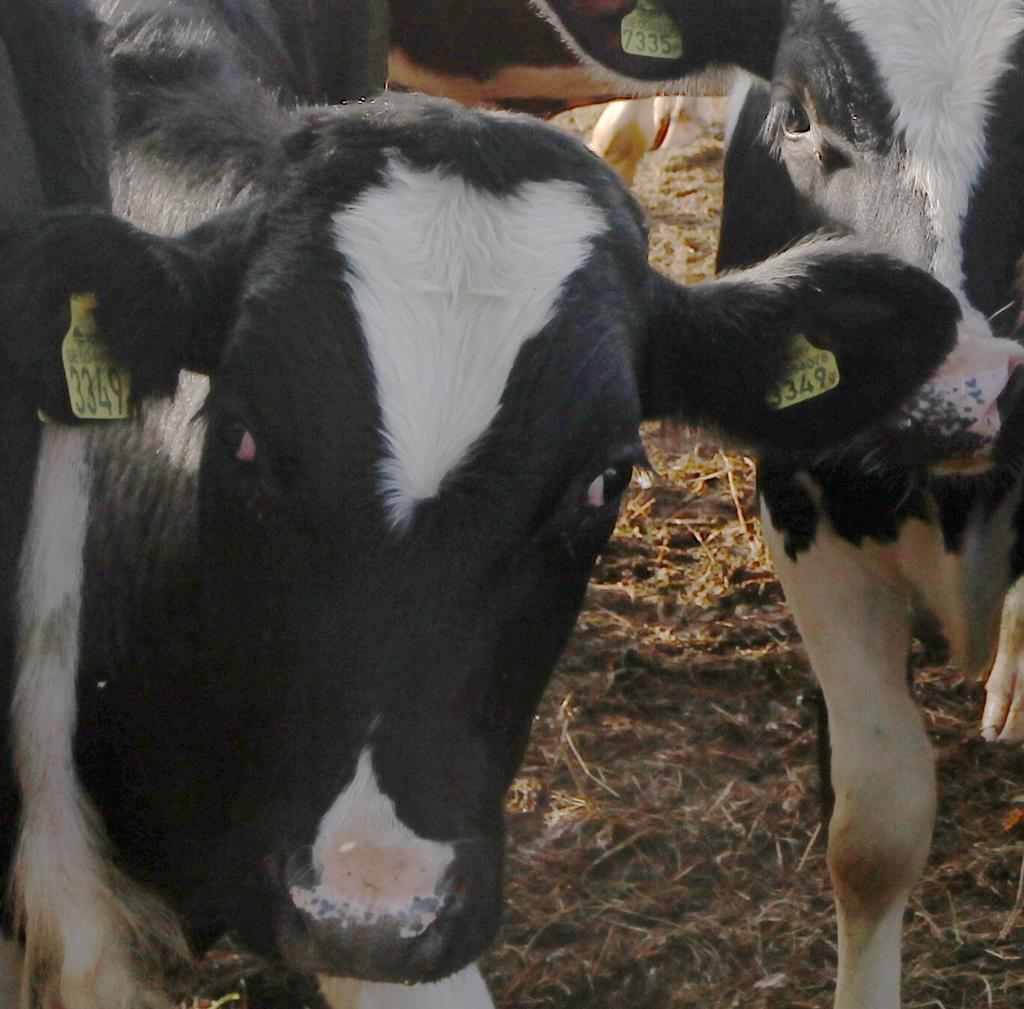What animals are present in the image? There are many cows in the image. What are the cows doing in the image? The cows are looking at someone. What type of skirt is the cow wearing in the image? There are no cows wearing skirts in the image, as cows do not wear clothing. 